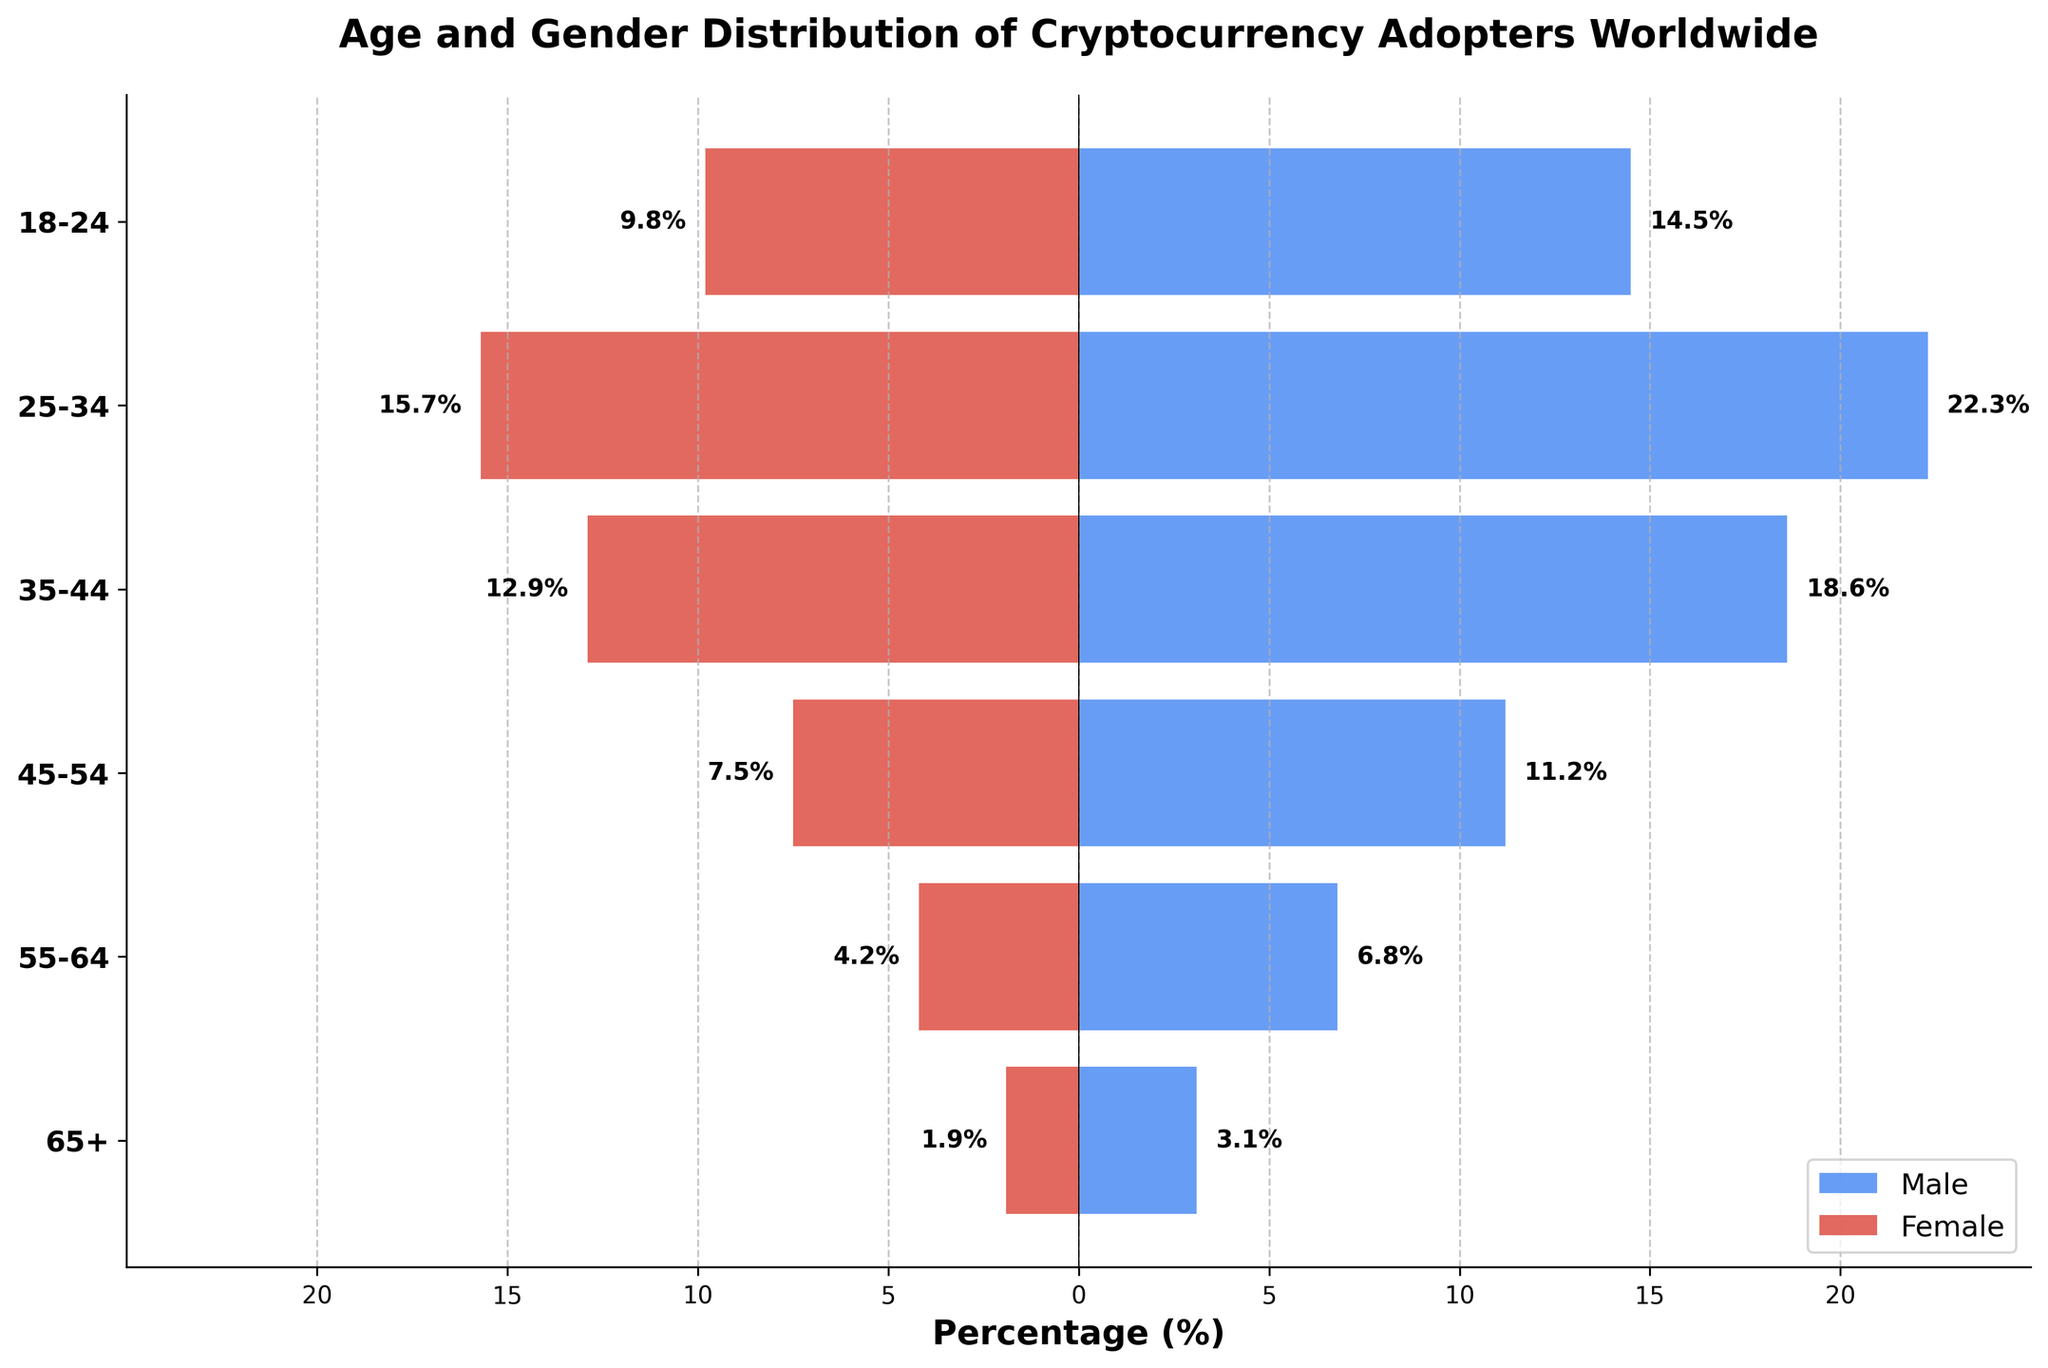What's the title of the figure? The title of the figure is printed at the top of the plot in a larger and bold font. It reads "Age and Gender Distribution of Cryptocurrency Adopters Worldwide."
Answer: Age and Gender Distribution of Cryptocurrency Adopters Worldwide How many age groups are represented in the data? The y-axis lists the age groups with labels. Counting them, we see there are six age groups: "18-24", "25-34", "35-44", "45-54", "55-64", and "65+."
Answer: 6 What percentage of female cryptocurrency adopters are aged 25-34? The bar representing female adopters aged 25-34 appears on the left side of the pyramid as a negative bar. The label on the bar shows the percentage, which is 15.7%.
Answer: 15.7% Which age group has the highest percentage of male cryptocurrency adopters? We compare the lengths of the blue bars representing male adopters across all age groups. The age group "25-34" has the longest blue bar, labeled 22.3%, indicating the highest percentage of male adopters.
Answer: 25-34 Is the percentage of female adopters higher or lower than male adopters in the 45-54 age group? We look at the bars for the 45-54 age group. The blue bar representing males is at 11.2%, while the red bar representing females is at 7.5%. The male percentage is higher.
Answer: Lower What is the combined percentage of male adopters in the 25-34 and 35-44 age groups? The male percentages for the 25-34 and 35-44 age groups are 22.3% and 18.6%, respectively. Adding these gives 22.3 + 18.6 = 40.9%.
Answer: 40.9% How does the percentage of female adopters aged 65+ compare to male adopters in the same group? The bars for the 65+ age group show that the female percentage is 1.9%, while the male percentage is 3.1%. The female percentage is lower.
Answer: Lower What is the total percentage of cryptocurrency adopters (both genders) aged 55-64? We sum the male and female percentages for the 55-64 age group. The male percentage is 6.8%, and the female percentage is 4.2%. Adding these gives 6.8 + 4.2 = 11.0%.
Answer: 11.0% At which age group is the gap between male and female adopters the largest, and what is the gap? We calculate the difference between male and female percentages for each age group. The largest gap is for the 25-34 age group, with 22.3% - 15.7% = 6.6%.
Answer: 25-34, 6.6% What is the average percentage of female cryptocurrency adopters across all age groups? We sum the female percentages across age groups (9.8% + 15.7% + 12.9% + 7.5% + 4.2% + 1.9%) and divide by the number of groups (6). The sum is 52, so the average is 52/6 = 8.67%.
Answer: 8.67% 